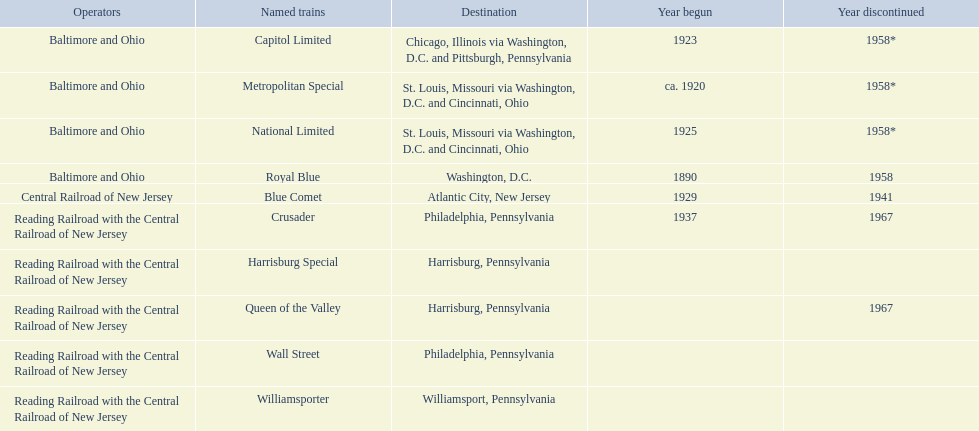Which operators are associated with the reading railroad and the central railroad of new jersey? Reading Railroad with the Central Railroad of New Jersey, Reading Railroad with the Central Railroad of New Jersey, Reading Railroad with the Central Railroad of New Jersey, Reading Railroad with the Central Railroad of New Jersey, Reading Railroad with the Central Railroad of New Jersey. What destinations are in philadelphia, pennsylvania? Philadelphia, Pennsylvania, Philadelphia, Pennsylvania. What event started in 1937? 1937. What is the title of the train? Crusader. 